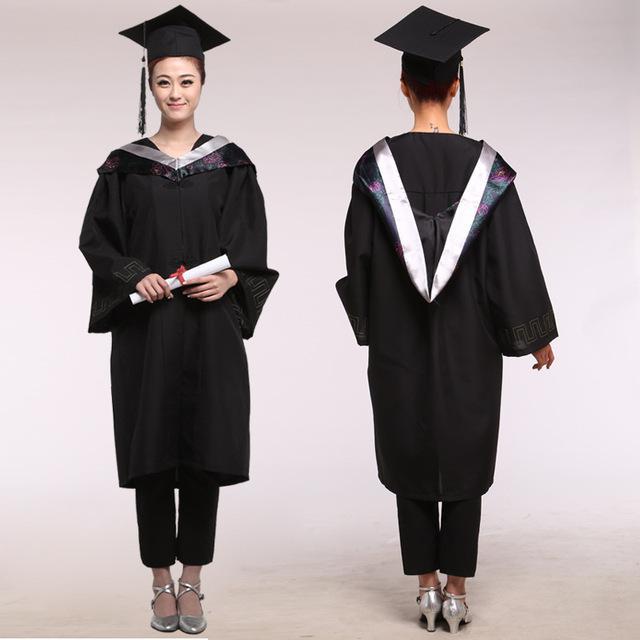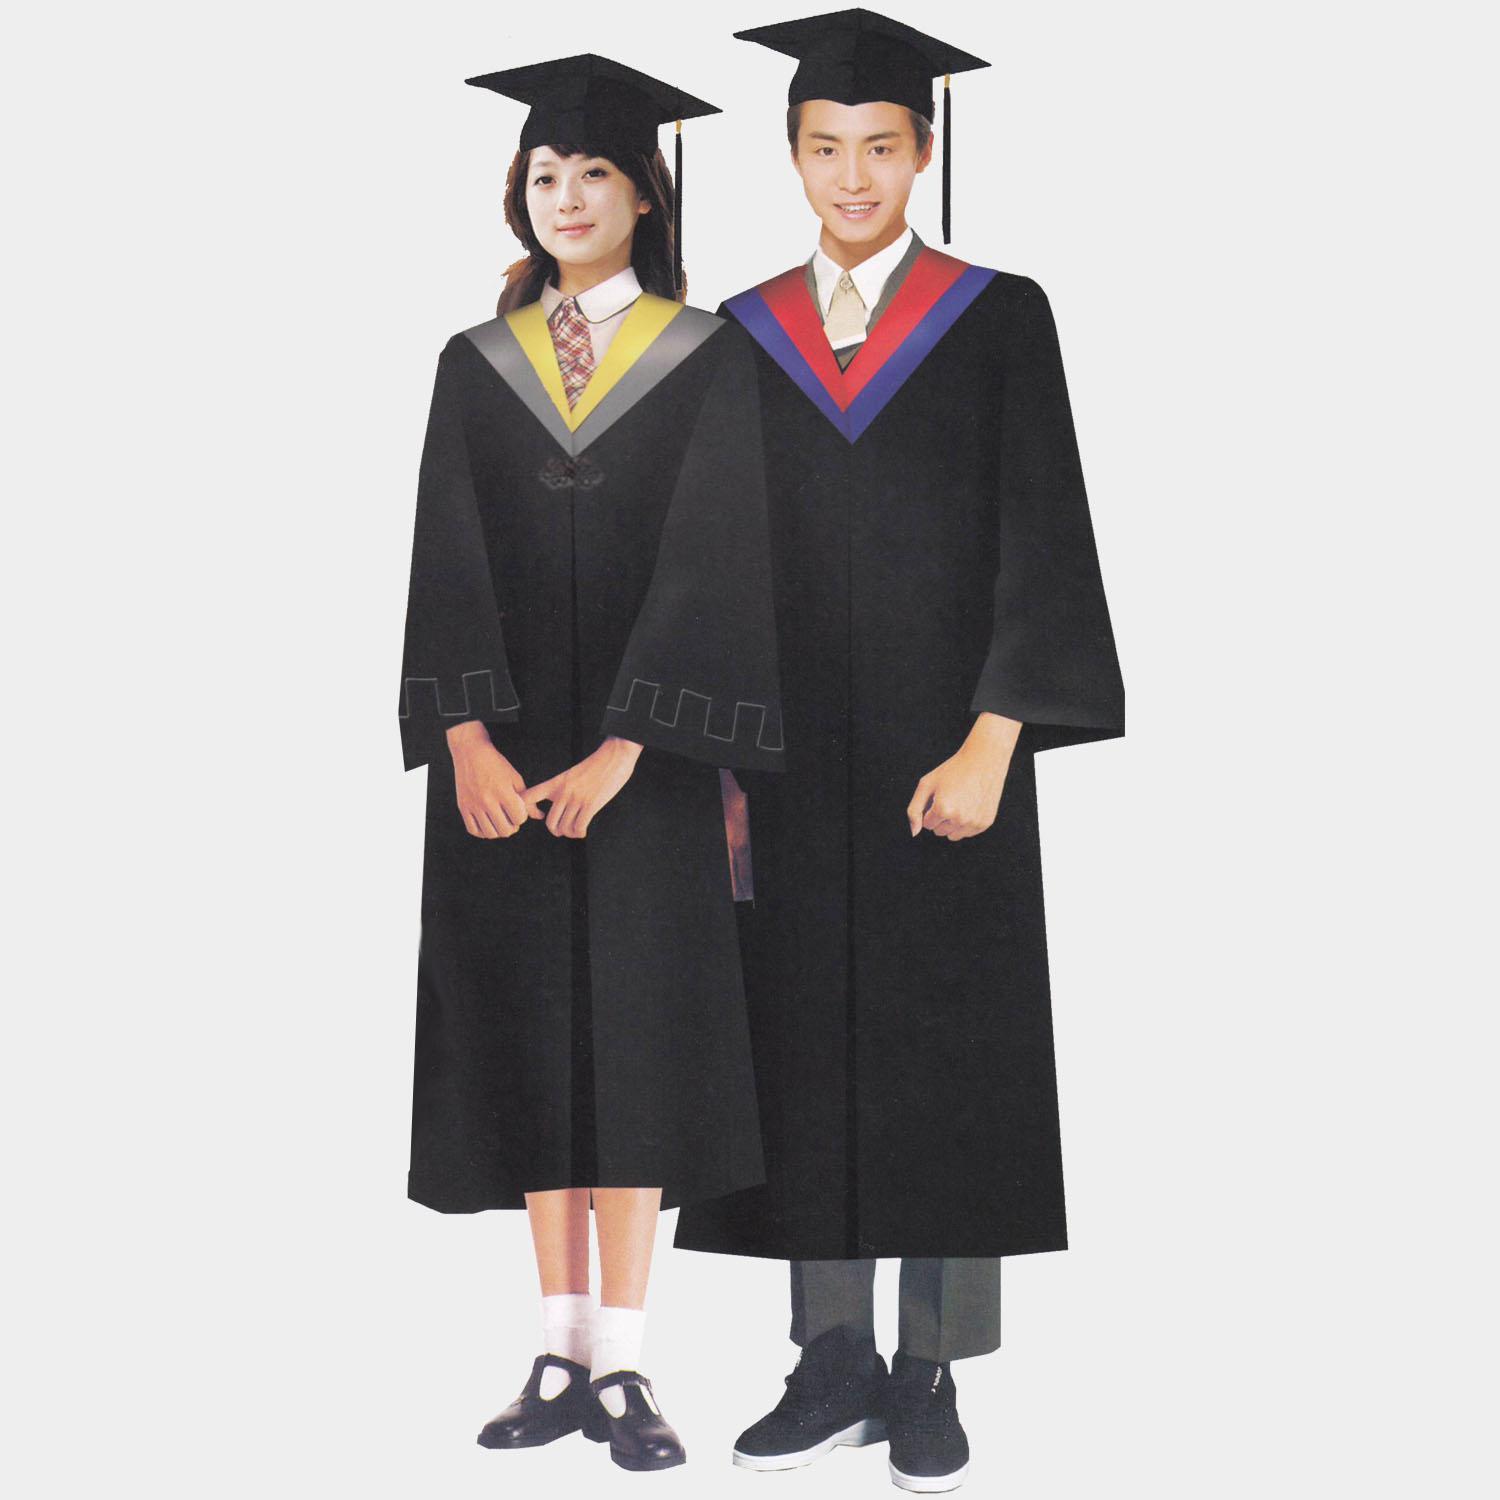The first image is the image on the left, the second image is the image on the right. For the images displayed, is the sentence "An image shows front and rear views of a graduation model." factually correct? Answer yes or no. Yes. The first image is the image on the left, the second image is the image on the right. For the images displayed, is the sentence "There are exactly two people shown in both of the images." factually correct? Answer yes or no. Yes. The first image is the image on the left, the second image is the image on the right. Examine the images to the left and right. Is the description "There are exactly two people in the image on the right." accurate? Answer yes or no. Yes. 